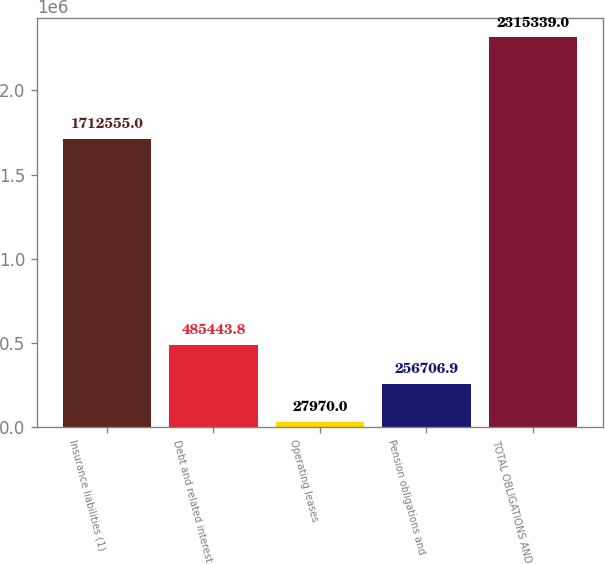<chart> <loc_0><loc_0><loc_500><loc_500><bar_chart><fcel>Insurance liabilities (1)<fcel>Debt and related interest<fcel>Operating leases<fcel>Pension obligations and<fcel>TOTAL OBLIGATIONS AND<nl><fcel>1.71256e+06<fcel>485444<fcel>27970<fcel>256707<fcel>2.31534e+06<nl></chart> 